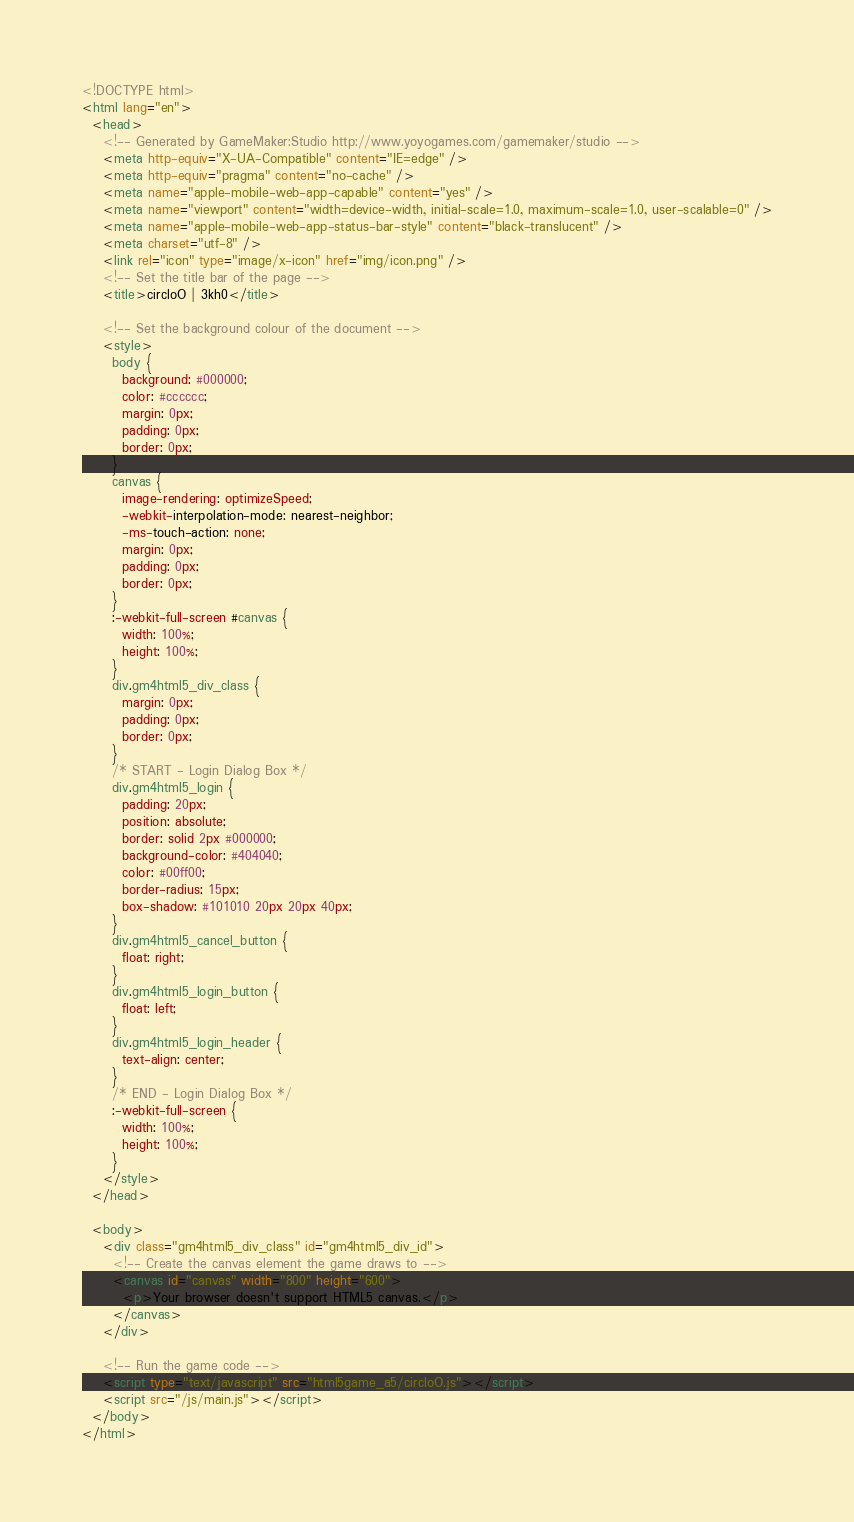<code> <loc_0><loc_0><loc_500><loc_500><_HTML_><!DOCTYPE html>
<html lang="en">
  <head>
    <!-- Generated by GameMaker:Studio http://www.yoyogames.com/gamemaker/studio -->
    <meta http-equiv="X-UA-Compatible" content="IE=edge" />
    <meta http-equiv="pragma" content="no-cache" />
    <meta name="apple-mobile-web-app-capable" content="yes" />
    <meta name="viewport" content="width=device-width, initial-scale=1.0, maximum-scale=1.0, user-scalable=0" />
    <meta name="apple-mobile-web-app-status-bar-style" content="black-translucent" />
    <meta charset="utf-8" />
    <link rel="icon" type="image/x-icon" href="img/icon.png" />
    <!-- Set the title bar of the page -->
    <title>circloO | 3kh0</title>

    <!-- Set the background colour of the document -->
    <style>
      body {
        background: #000000;
        color: #cccccc;
        margin: 0px;
        padding: 0px;
        border: 0px;
      }
      canvas {
        image-rendering: optimizeSpeed;
        -webkit-interpolation-mode: nearest-neighbor;
        -ms-touch-action: none;
        margin: 0px;
        padding: 0px;
        border: 0px;
      }
      :-webkit-full-screen #canvas {
        width: 100%;
        height: 100%;
      }
      div.gm4html5_div_class {
        margin: 0px;
        padding: 0px;
        border: 0px;
      }
      /* START - Login Dialog Box */
      div.gm4html5_login {
        padding: 20px;
        position: absolute;
        border: solid 2px #000000;
        background-color: #404040;
        color: #00ff00;
        border-radius: 15px;
        box-shadow: #101010 20px 20px 40px;
      }
      div.gm4html5_cancel_button {
        float: right;
      }
      div.gm4html5_login_button {
        float: left;
      }
      div.gm4html5_login_header {
        text-align: center;
      }
      /* END - Login Dialog Box */
      :-webkit-full-screen {
        width: 100%;
        height: 100%;
      }
    </style>
  </head>

  <body>
    <div class="gm4html5_div_class" id="gm4html5_div_id">
      <!-- Create the canvas element the game draws to -->
      <canvas id="canvas" width="800" height="600">
        <p>Your browser doesn't support HTML5 canvas.</p>
      </canvas>
    </div>

    <!-- Run the game code -->
    <script type="text/javascript" src="html5game_a5/circloO.js"></script>
    <script src="/js/main.js"></script>
  </body>
</html></code> 